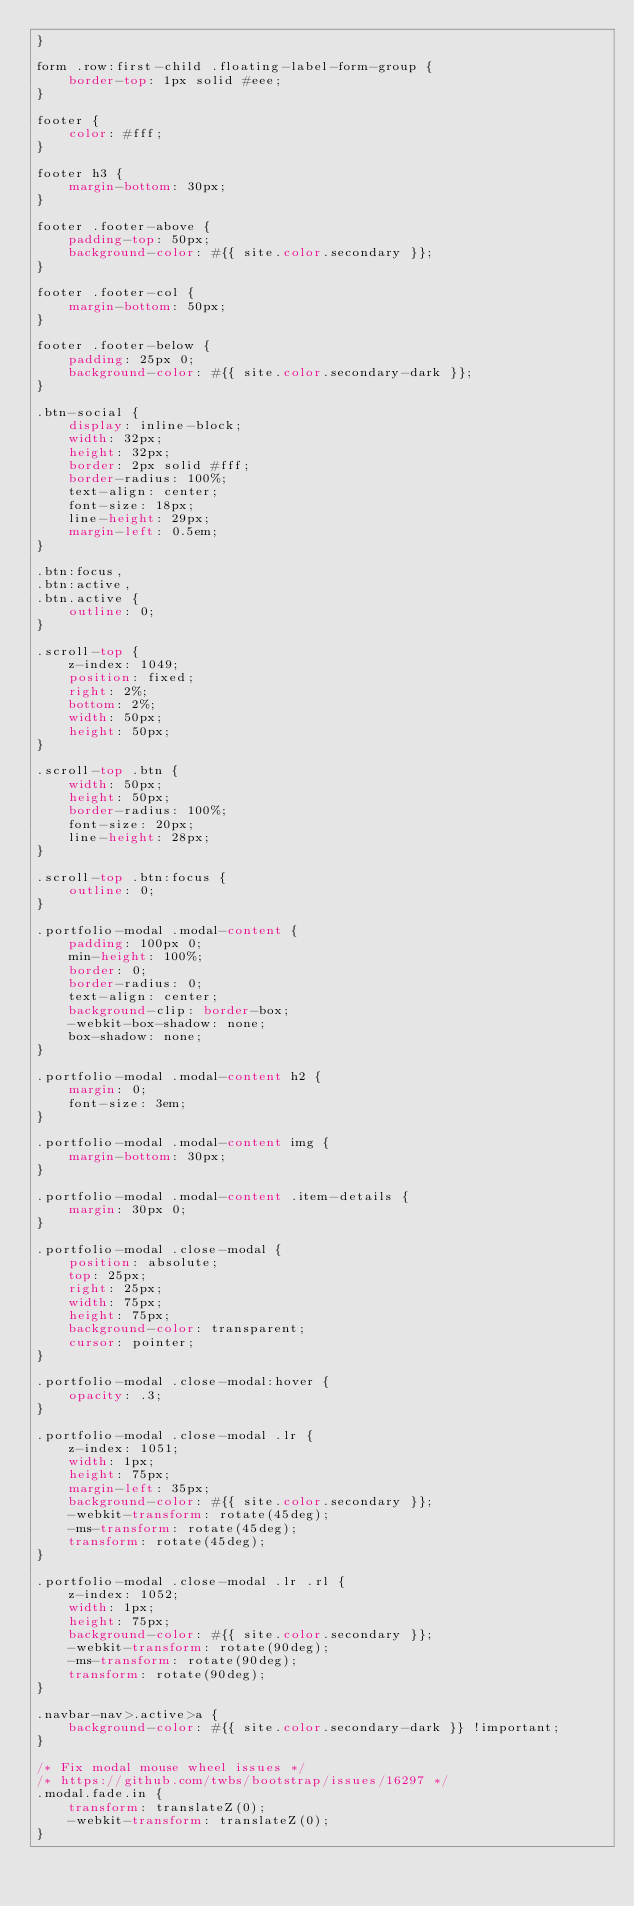<code> <loc_0><loc_0><loc_500><loc_500><_CSS_>}

form .row:first-child .floating-label-form-group {
    border-top: 1px solid #eee;
}

footer {
    color: #fff;
}

footer h3 {
    margin-bottom: 30px;
}

footer .footer-above {
    padding-top: 50px;
    background-color: #{{ site.color.secondary }};
}

footer .footer-col {
    margin-bottom: 50px;
}

footer .footer-below {
    padding: 25px 0;
    background-color: #{{ site.color.secondary-dark }};
}

.btn-social {
    display: inline-block;
    width: 32px;
    height: 32px;
    border: 2px solid #fff;
    border-radius: 100%;
    text-align: center;
    font-size: 18px;
    line-height: 29px;
    margin-left: 0.5em;
}

.btn:focus,
.btn:active,
.btn.active {
    outline: 0;
}

.scroll-top {
    z-index: 1049;
    position: fixed;
    right: 2%;
    bottom: 2%;
    width: 50px;
    height: 50px;
}

.scroll-top .btn {
    width: 50px;
    height: 50px;
    border-radius: 100%;
    font-size: 20px;
    line-height: 28px;
}

.scroll-top .btn:focus {
    outline: 0;
}

.portfolio-modal .modal-content {
    padding: 100px 0;
    min-height: 100%;
    border: 0;
    border-radius: 0;
    text-align: center;
    background-clip: border-box;
    -webkit-box-shadow: none;
    box-shadow: none;
}

.portfolio-modal .modal-content h2 {
    margin: 0;
    font-size: 3em;
}

.portfolio-modal .modal-content img {
    margin-bottom: 30px;
}

.portfolio-modal .modal-content .item-details {
    margin: 30px 0;
}

.portfolio-modal .close-modal {
    position: absolute;
    top: 25px;
    right: 25px;
    width: 75px;
    height: 75px;
    background-color: transparent;
    cursor: pointer;
}

.portfolio-modal .close-modal:hover {
    opacity: .3;
}

.portfolio-modal .close-modal .lr {
    z-index: 1051;
    width: 1px;
    height: 75px;
    margin-left: 35px;
    background-color: #{{ site.color.secondary }};
    -webkit-transform: rotate(45deg);
    -ms-transform: rotate(45deg);
    transform: rotate(45deg);
}

.portfolio-modal .close-modal .lr .rl {
    z-index: 1052;
    width: 1px;
    height: 75px;
    background-color: #{{ site.color.secondary }};
    -webkit-transform: rotate(90deg);
    -ms-transform: rotate(90deg);
    transform: rotate(90deg);
}

.navbar-nav>.active>a {
    background-color: #{{ site.color.secondary-dark }} !important;
}

/* Fix modal mouse wheel issues */
/* https://github.com/twbs/bootstrap/issues/16297 */
.modal.fade.in {
    transform: translateZ(0);
    -webkit-transform: translateZ(0);
}
</code> 